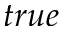Convert formula to latex. <formula><loc_0><loc_0><loc_500><loc_500>t r u e</formula> 